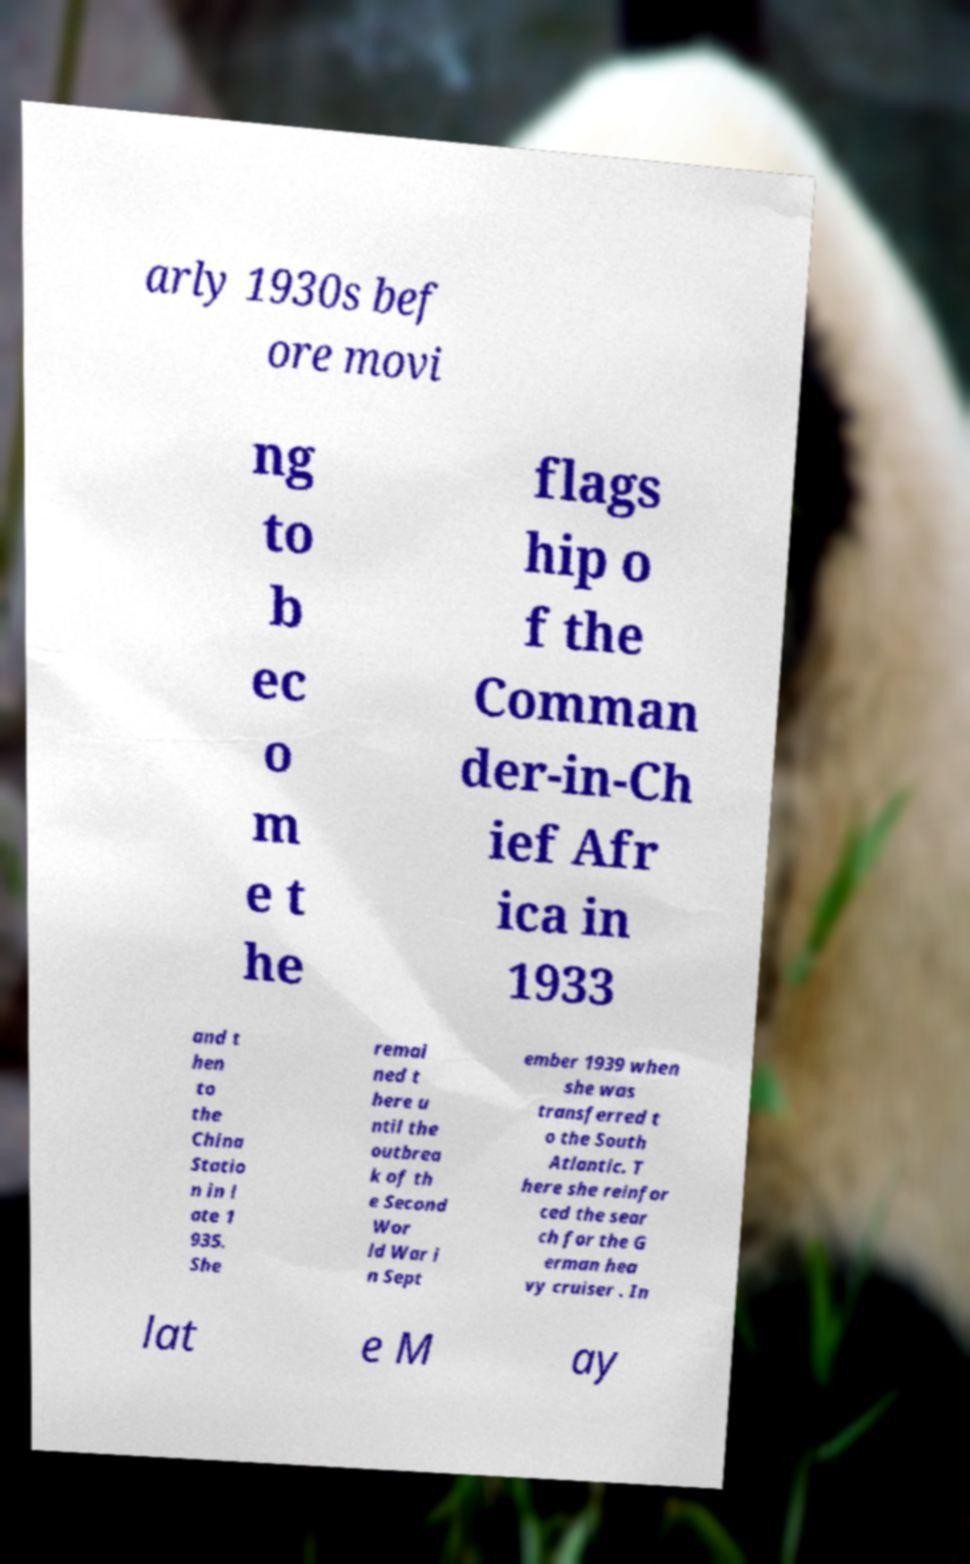Please identify and transcribe the text found in this image. arly 1930s bef ore movi ng to b ec o m e t he flags hip o f the Comman der-in-Ch ief Afr ica in 1933 and t hen to the China Statio n in l ate 1 935. She remai ned t here u ntil the outbrea k of th e Second Wor ld War i n Sept ember 1939 when she was transferred t o the South Atlantic. T here she reinfor ced the sear ch for the G erman hea vy cruiser . In lat e M ay 